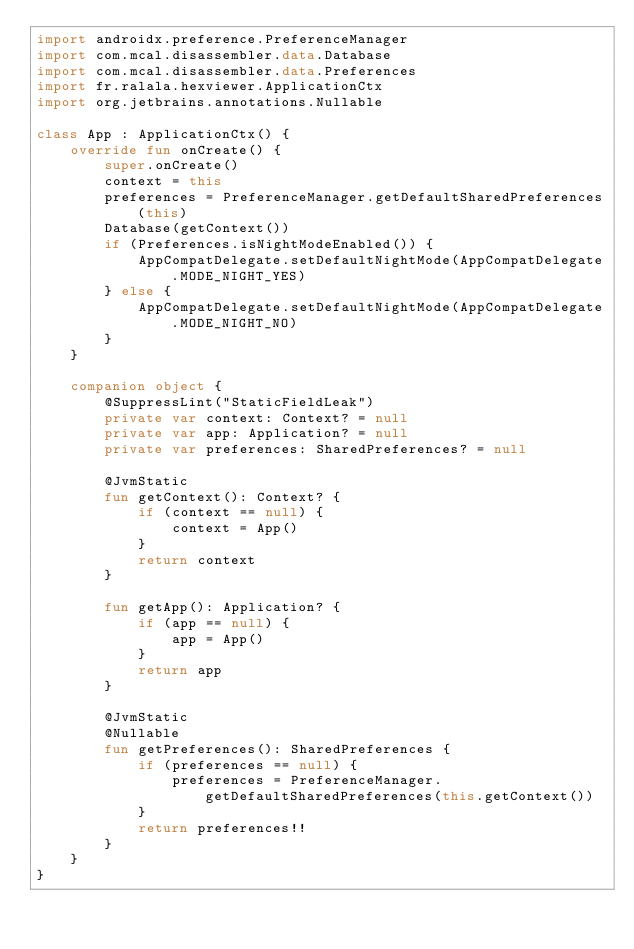Convert code to text. <code><loc_0><loc_0><loc_500><loc_500><_Kotlin_>import androidx.preference.PreferenceManager
import com.mcal.disassembler.data.Database
import com.mcal.disassembler.data.Preferences
import fr.ralala.hexviewer.ApplicationCtx
import org.jetbrains.annotations.Nullable

class App : ApplicationCtx() {
    override fun onCreate() {
        super.onCreate()
        context = this
        preferences = PreferenceManager.getDefaultSharedPreferences(this)
        Database(getContext())
        if (Preferences.isNightModeEnabled()) {
            AppCompatDelegate.setDefaultNightMode(AppCompatDelegate.MODE_NIGHT_YES)
        } else {
            AppCompatDelegate.setDefaultNightMode(AppCompatDelegate.MODE_NIGHT_NO)
        }
    }

    companion object {
        @SuppressLint("StaticFieldLeak")
        private var context: Context? = null
        private var app: Application? = null
        private var preferences: SharedPreferences? = null

        @JvmStatic
        fun getContext(): Context? {
            if (context == null) {
                context = App()
            }
            return context
        }

        fun getApp(): Application? {
            if (app == null) {
                app = App()
            }
            return app
        }

        @JvmStatic
        @Nullable
        fun getPreferences(): SharedPreferences {
            if (preferences == null) {
                preferences = PreferenceManager.getDefaultSharedPreferences(this.getContext())
            }
            return preferences!!
        }
    }
}</code> 